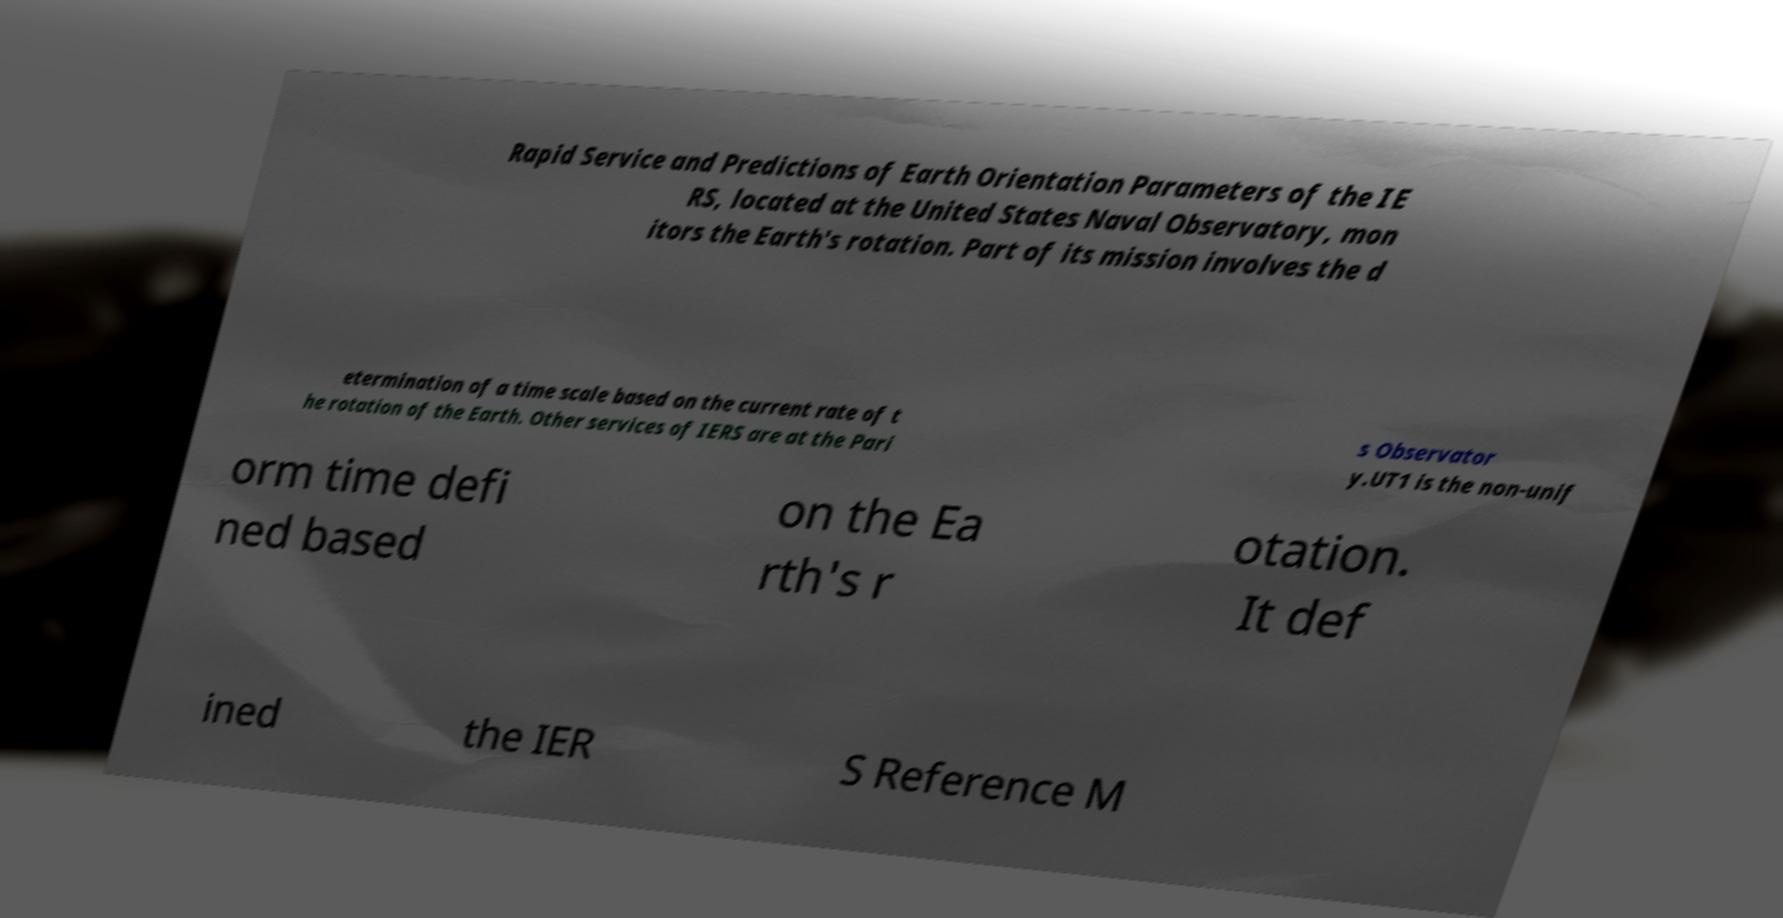Can you read and provide the text displayed in the image?This photo seems to have some interesting text. Can you extract and type it out for me? Rapid Service and Predictions of Earth Orientation Parameters of the IE RS, located at the United States Naval Observatory, mon itors the Earth's rotation. Part of its mission involves the d etermination of a time scale based on the current rate of t he rotation of the Earth. Other services of IERS are at the Pari s Observator y.UT1 is the non-unif orm time defi ned based on the Ea rth's r otation. It def ined the IER S Reference M 